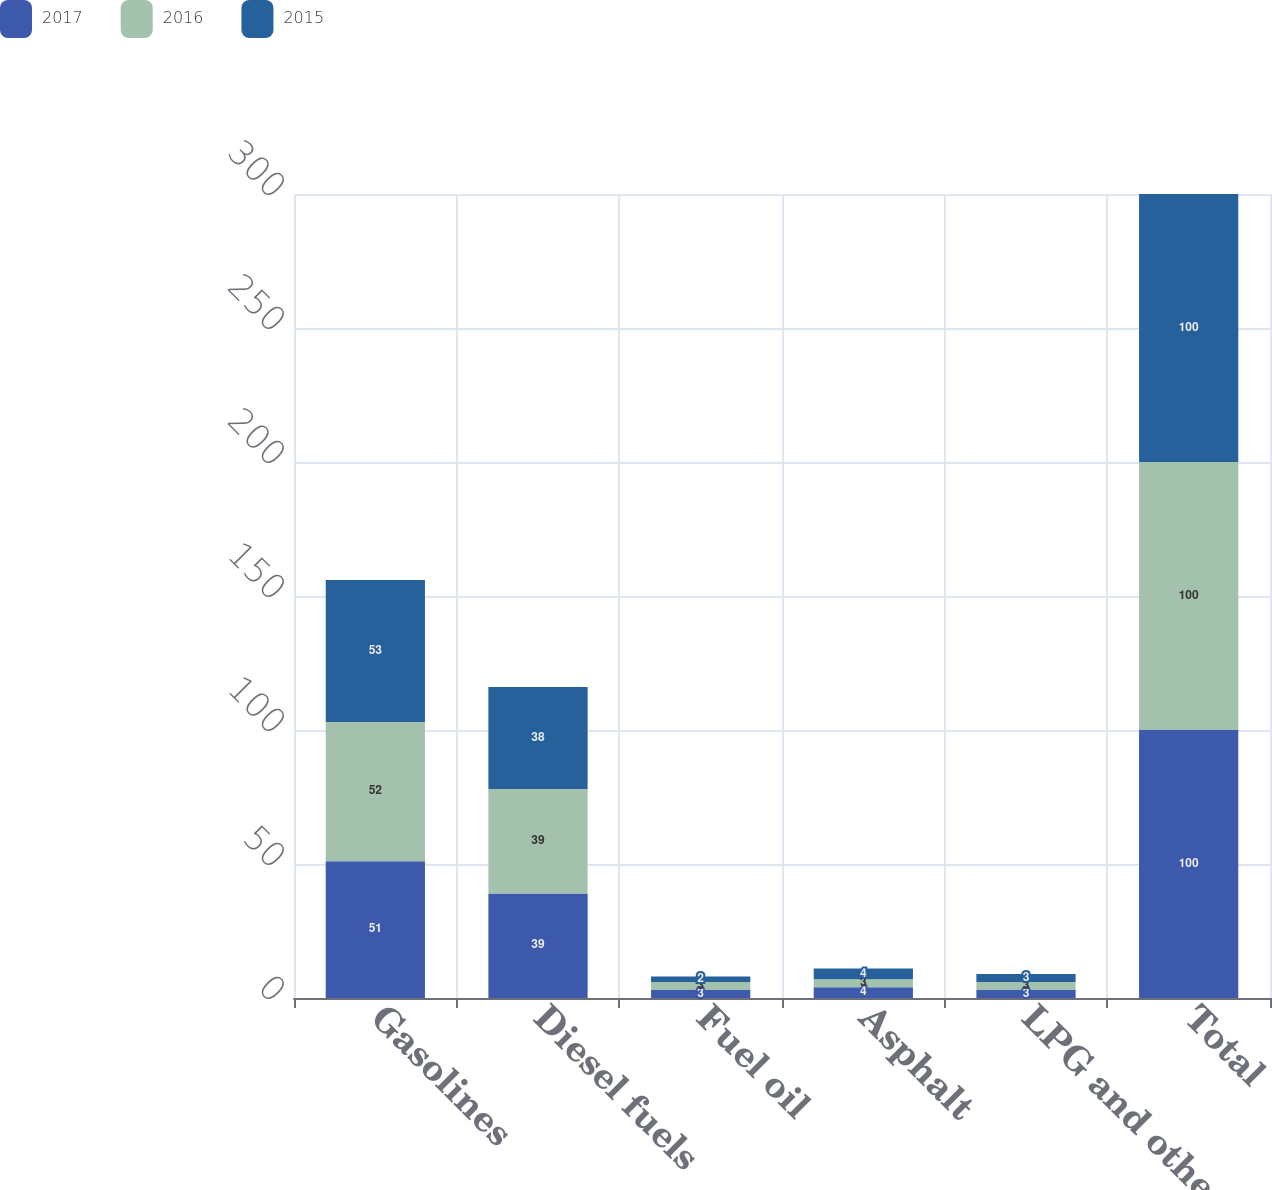<chart> <loc_0><loc_0><loc_500><loc_500><stacked_bar_chart><ecel><fcel>Gasolines<fcel>Diesel fuels<fcel>Fuel oil<fcel>Asphalt<fcel>LPG and other<fcel>Total<nl><fcel>2017<fcel>51<fcel>39<fcel>3<fcel>4<fcel>3<fcel>100<nl><fcel>2016<fcel>52<fcel>39<fcel>3<fcel>3<fcel>3<fcel>100<nl><fcel>2015<fcel>53<fcel>38<fcel>2<fcel>4<fcel>3<fcel>100<nl></chart> 